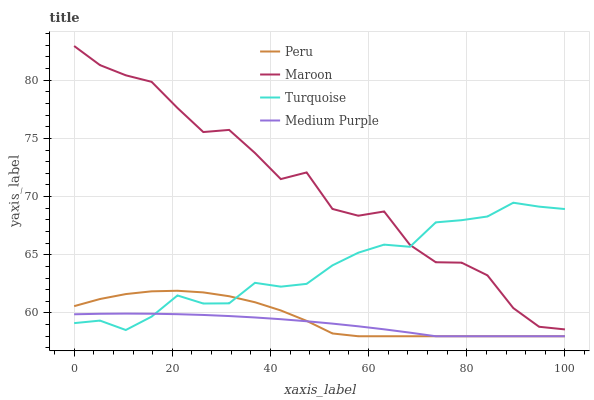Does Medium Purple have the minimum area under the curve?
Answer yes or no. Yes. Does Maroon have the maximum area under the curve?
Answer yes or no. Yes. Does Turquoise have the minimum area under the curve?
Answer yes or no. No. Does Turquoise have the maximum area under the curve?
Answer yes or no. No. Is Medium Purple the smoothest?
Answer yes or no. Yes. Is Maroon the roughest?
Answer yes or no. Yes. Is Turquoise the smoothest?
Answer yes or no. No. Is Turquoise the roughest?
Answer yes or no. No. Does Medium Purple have the lowest value?
Answer yes or no. Yes. Does Turquoise have the lowest value?
Answer yes or no. No. Does Maroon have the highest value?
Answer yes or no. Yes. Does Turquoise have the highest value?
Answer yes or no. No. Is Peru less than Maroon?
Answer yes or no. Yes. Is Maroon greater than Medium Purple?
Answer yes or no. Yes. Does Maroon intersect Turquoise?
Answer yes or no. Yes. Is Maroon less than Turquoise?
Answer yes or no. No. Is Maroon greater than Turquoise?
Answer yes or no. No. Does Peru intersect Maroon?
Answer yes or no. No. 